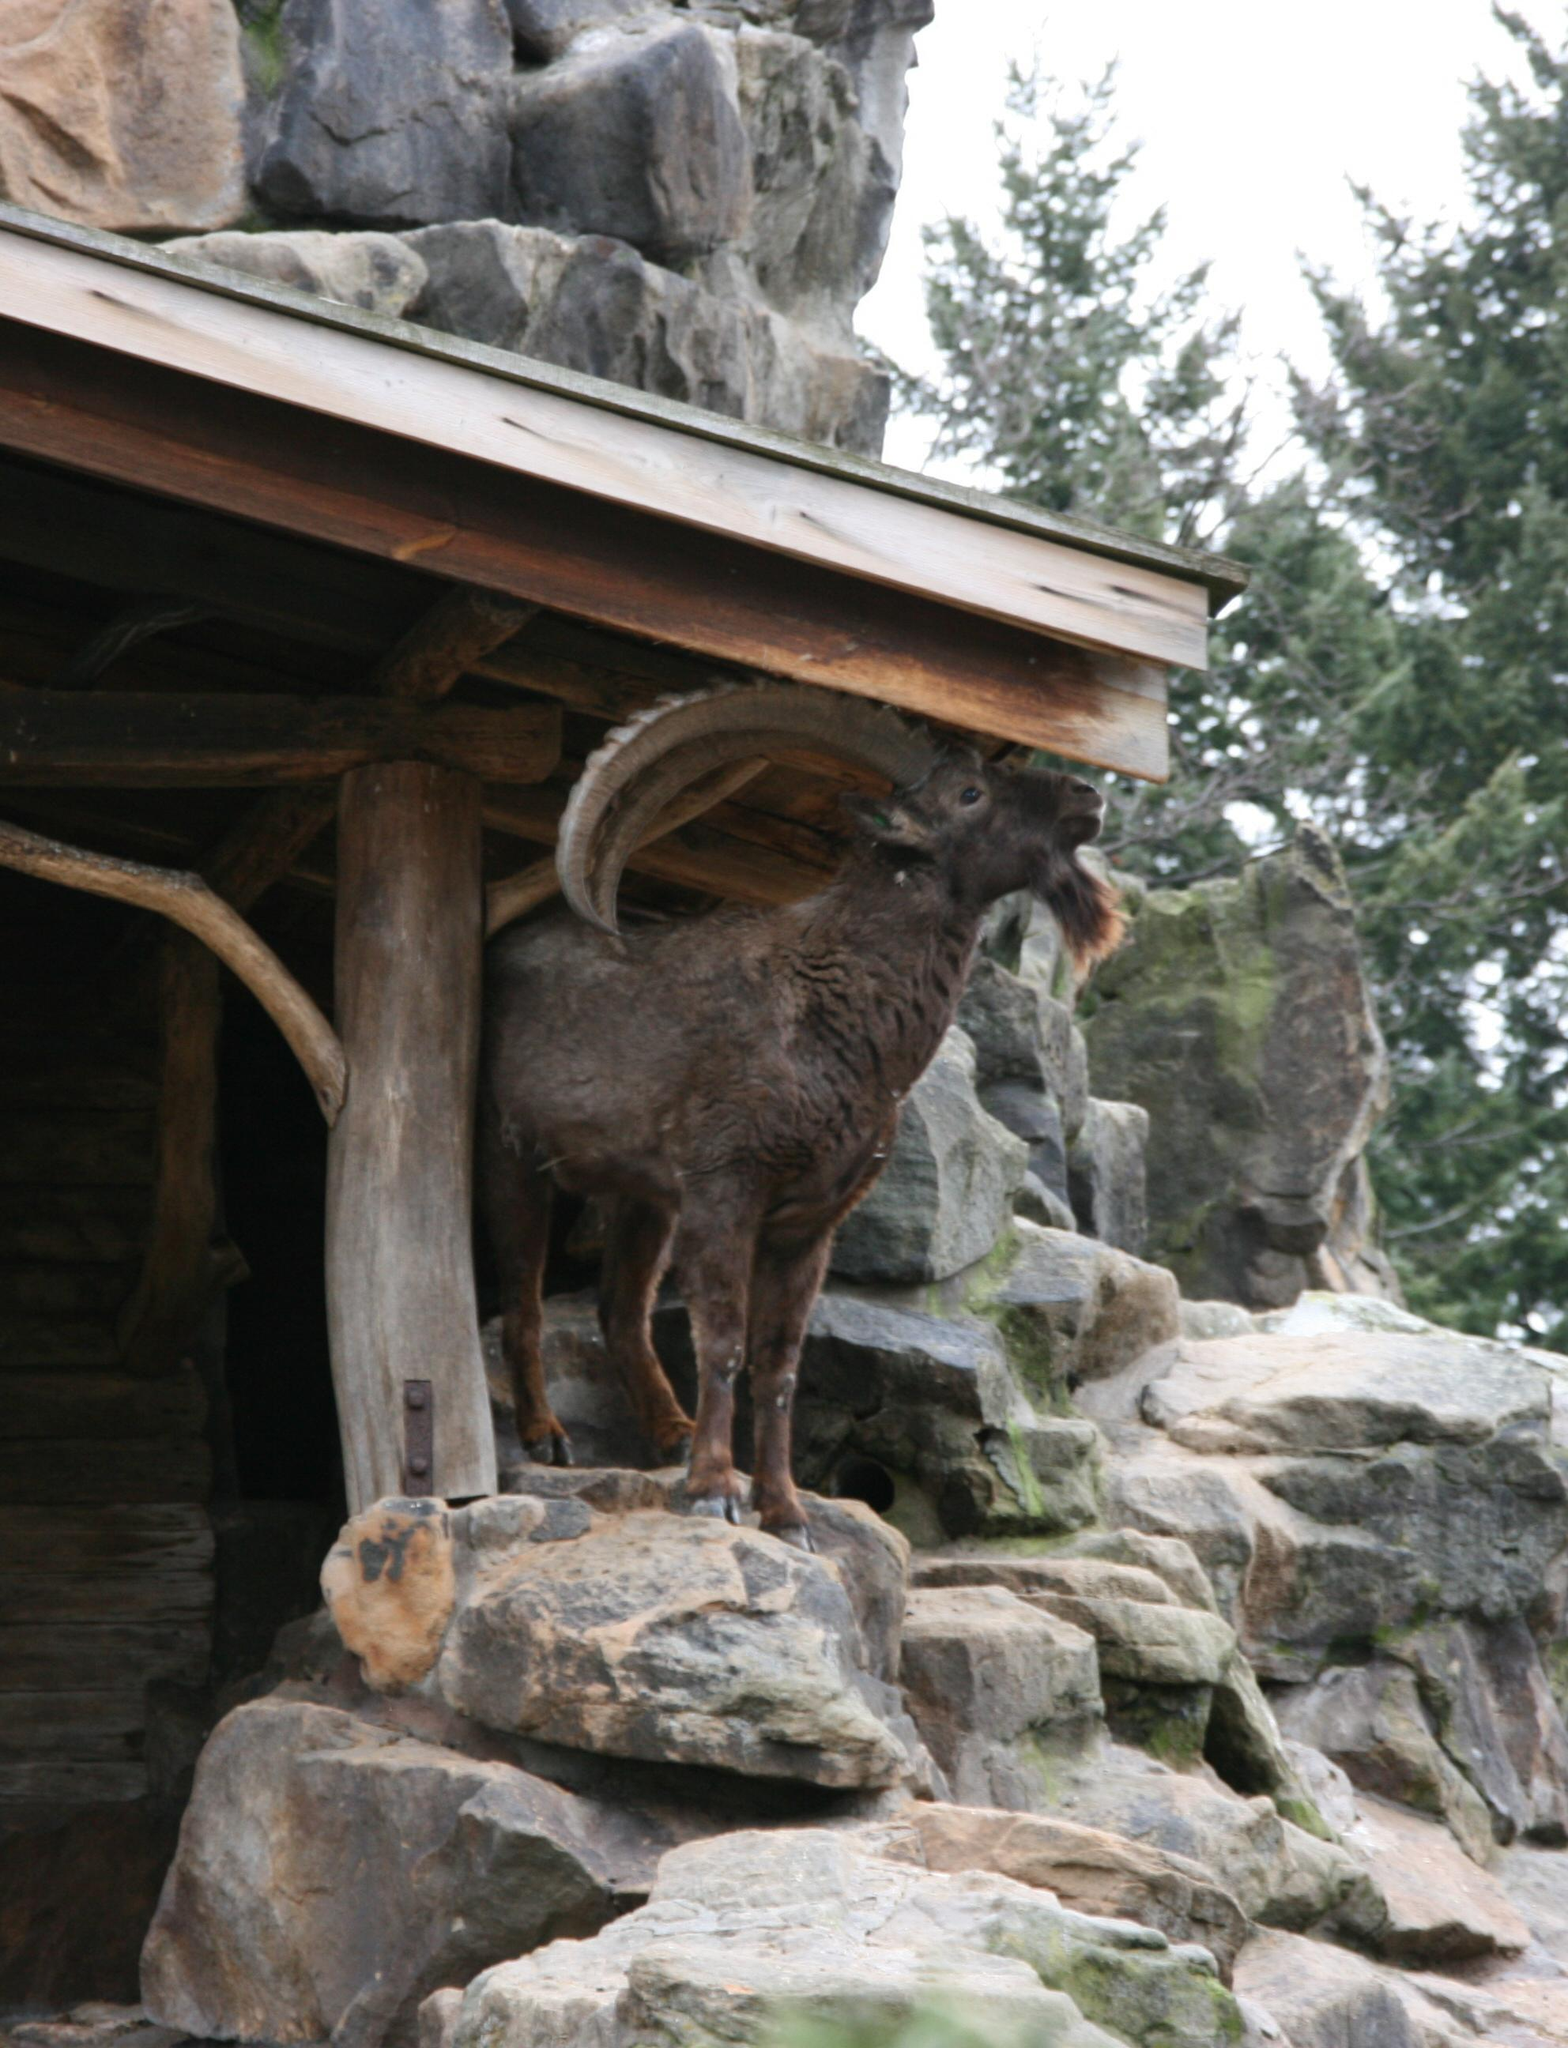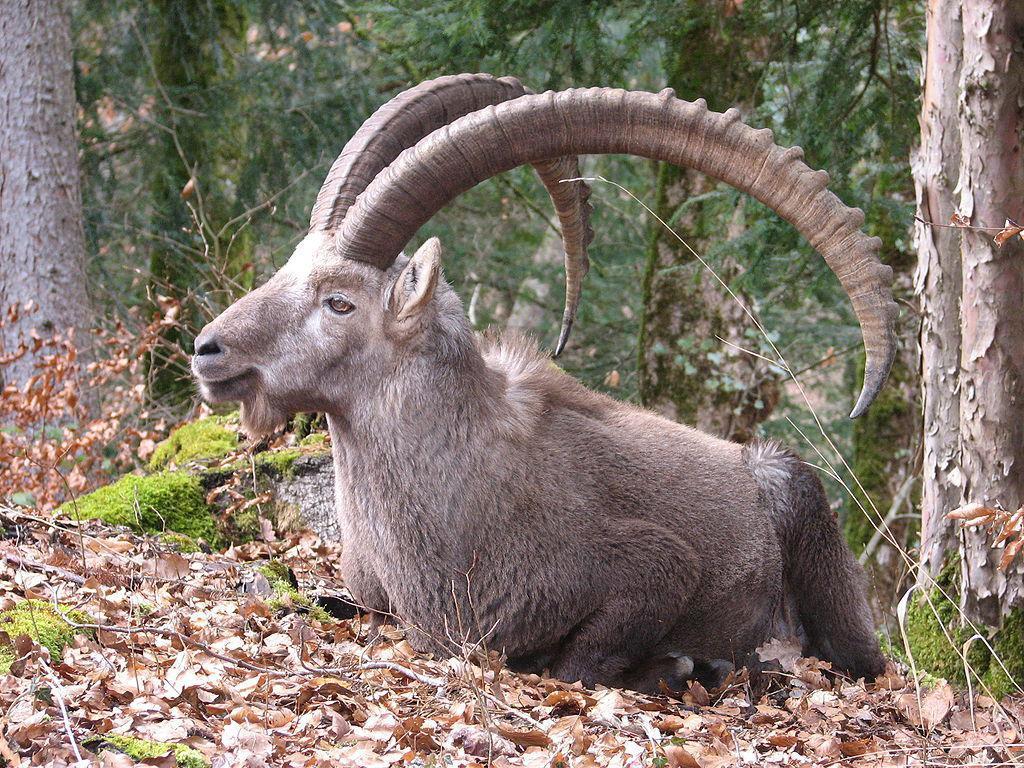The first image is the image on the left, the second image is the image on the right. For the images shown, is this caption "the animals in the image on the left are on grass" true? Answer yes or no. No. The first image is the image on the left, the second image is the image on the right. For the images shown, is this caption "The roof of a structure is visible in an image containing a horned goat." true? Answer yes or no. Yes. 